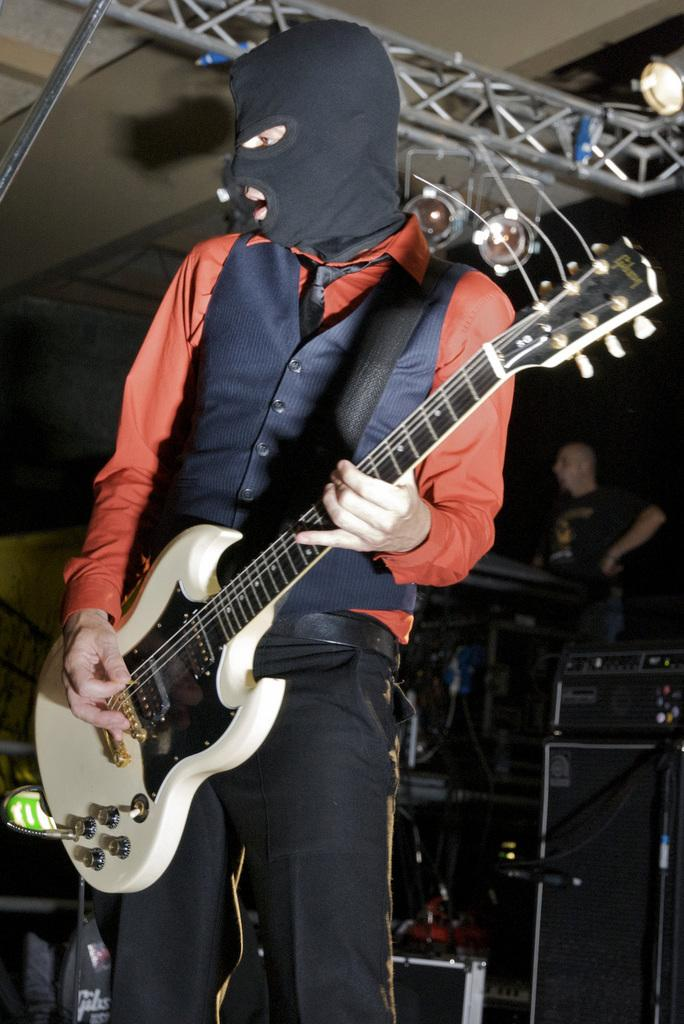What is the main subject of the image? The main subject of the image is a person holding a guitar. Can you describe the person's surroundings? There is another person standing in the background of the image. What else can be seen in the image? There are additional musical instruments visible in the image. What religion is the person in the image practicing? There is no information about the person's religion in the image. How many partners does the person in the image have? The image does not provide any information about the person's relationships or partners. 